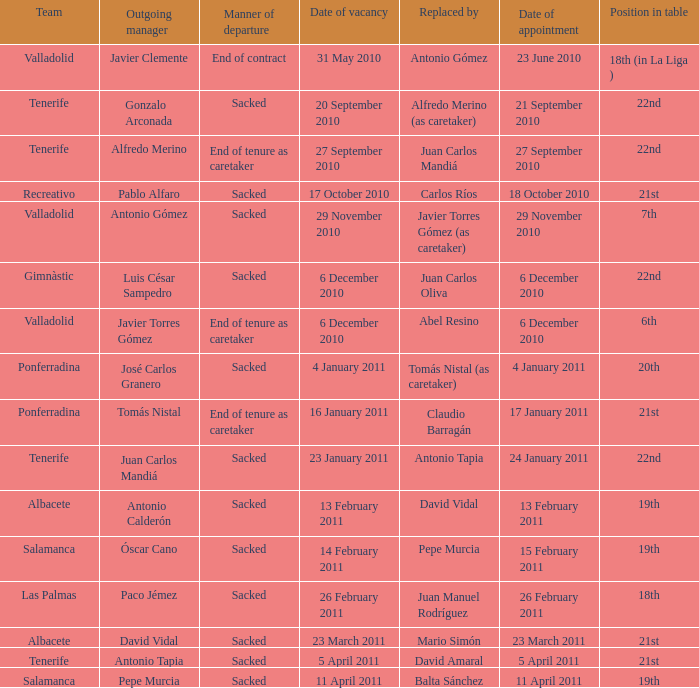What was the job title designated on 17 january 2011? 21st. 